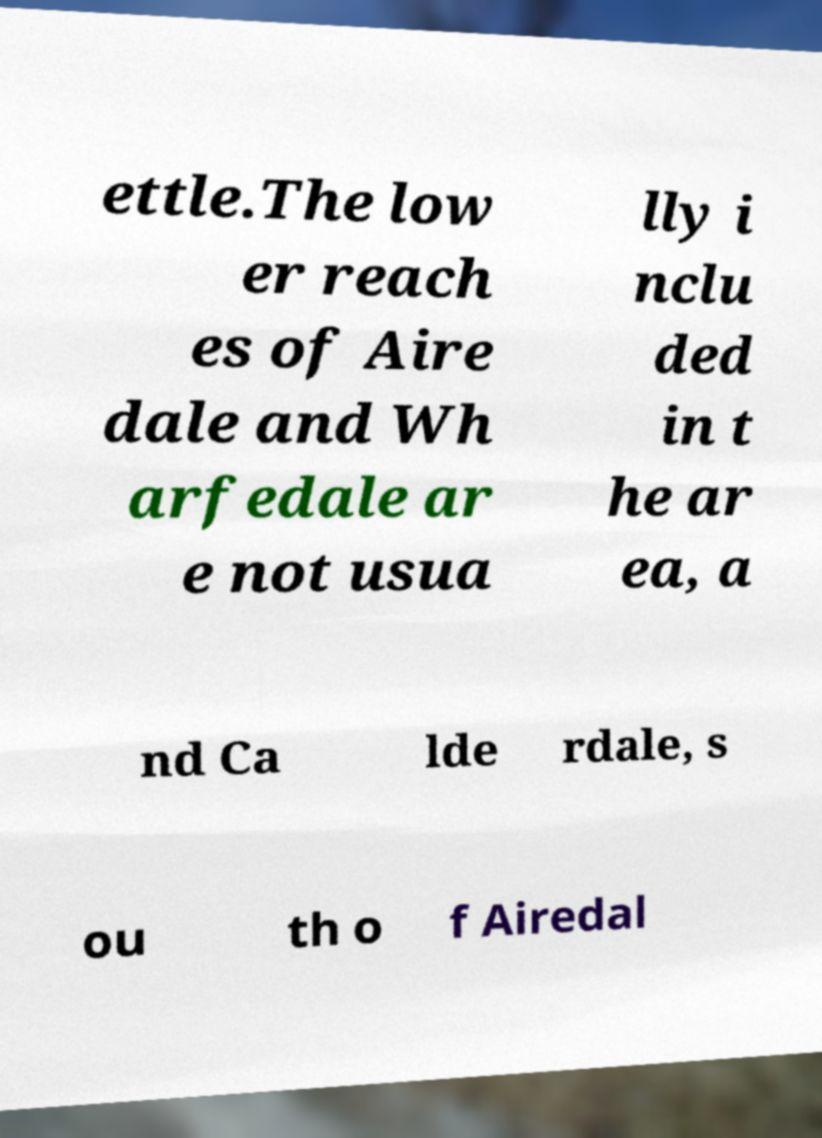Please read and relay the text visible in this image. What does it say? ettle.The low er reach es of Aire dale and Wh arfedale ar e not usua lly i nclu ded in t he ar ea, a nd Ca lde rdale, s ou th o f Airedal 